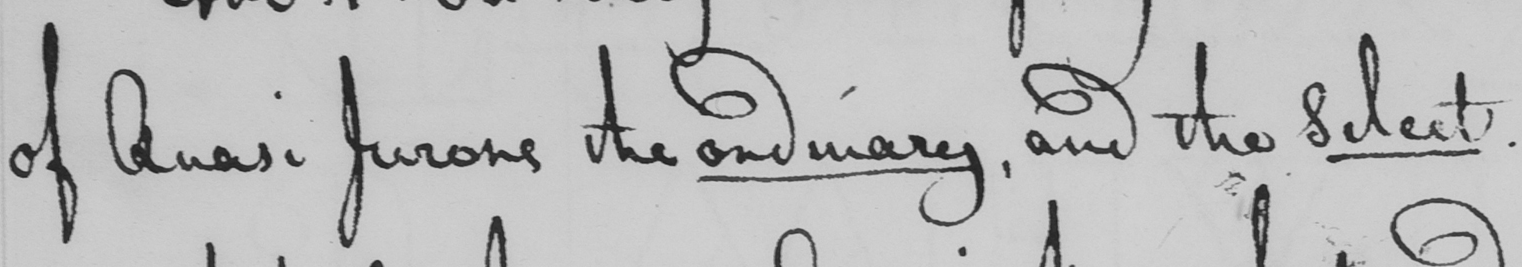What text is written in this handwritten line? of Quasi Jurors the ordinary , and the Select . 